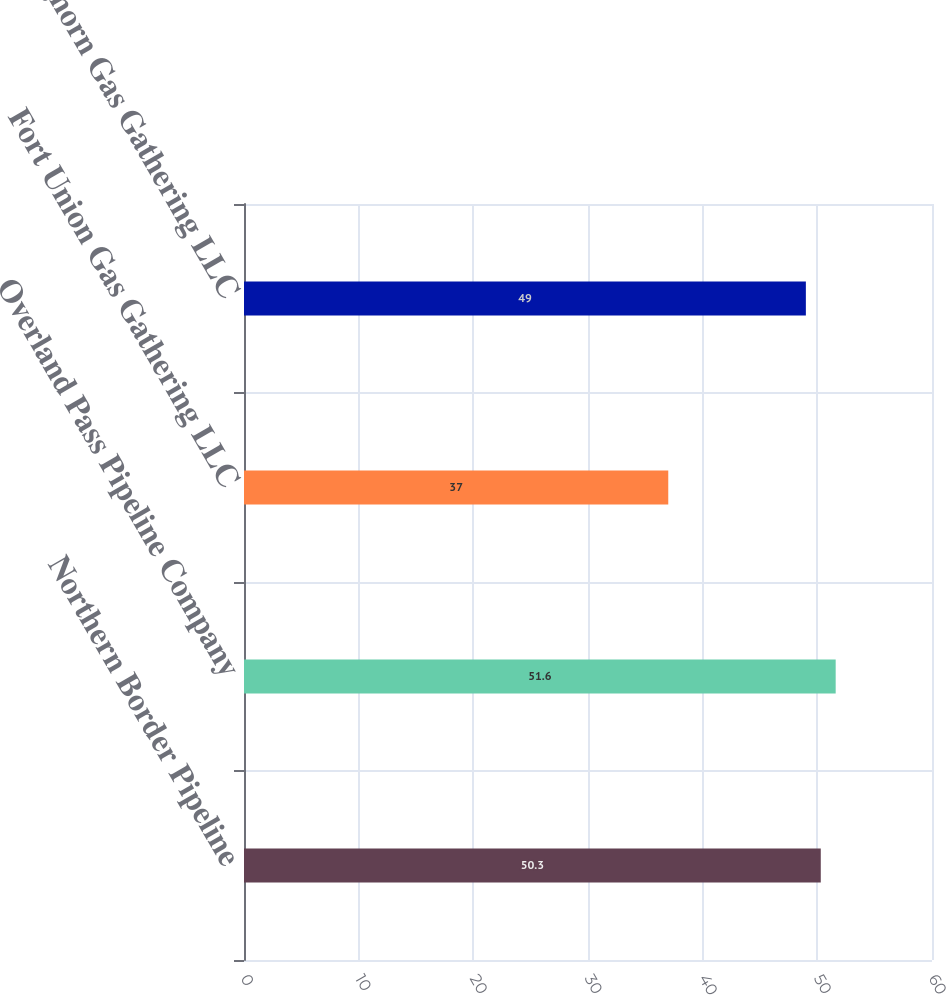Convert chart to OTSL. <chart><loc_0><loc_0><loc_500><loc_500><bar_chart><fcel>Northern Border Pipeline<fcel>Overland Pass Pipeline Company<fcel>Fort Union Gas Gathering LLC<fcel>Bighorn Gas Gathering LLC<nl><fcel>50.3<fcel>51.6<fcel>37<fcel>49<nl></chart> 